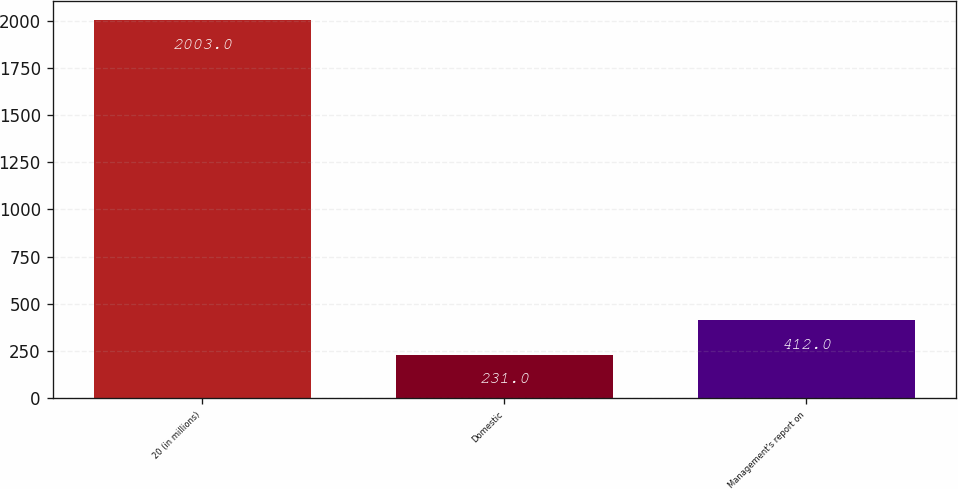<chart> <loc_0><loc_0><loc_500><loc_500><bar_chart><fcel>20 (in millions)<fcel>Domestic<fcel>Management's report on<nl><fcel>2003<fcel>231<fcel>412<nl></chart> 